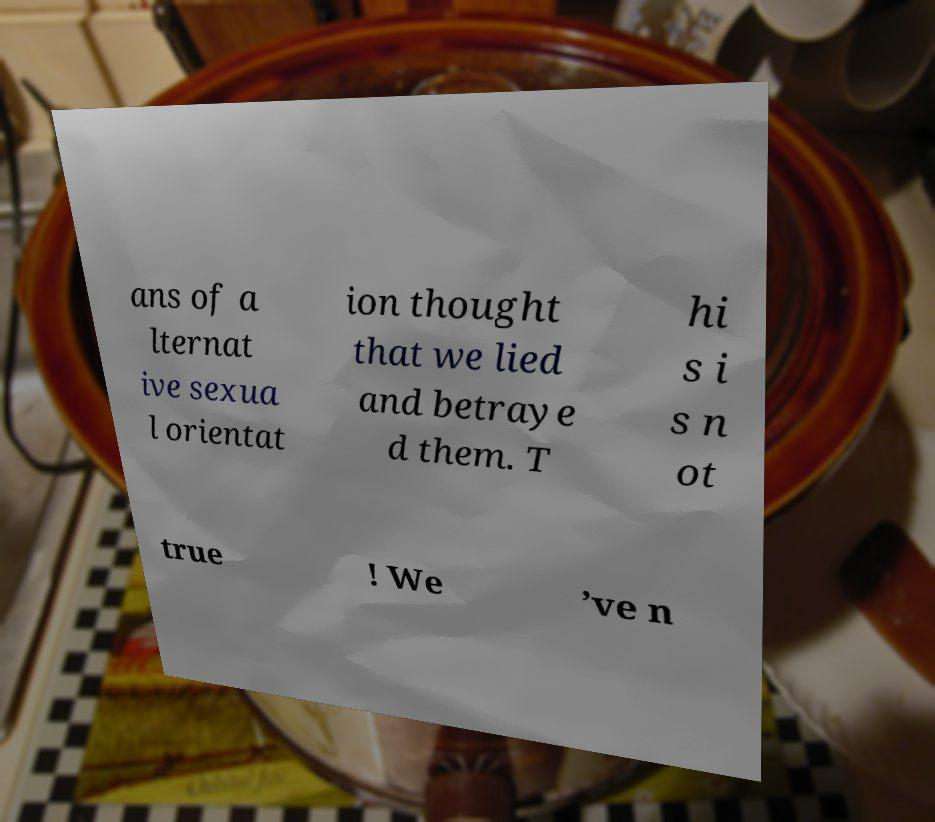Please read and relay the text visible in this image. What does it say? ans of a lternat ive sexua l orientat ion thought that we lied and betraye d them. T hi s i s n ot true ! We ’ve n 